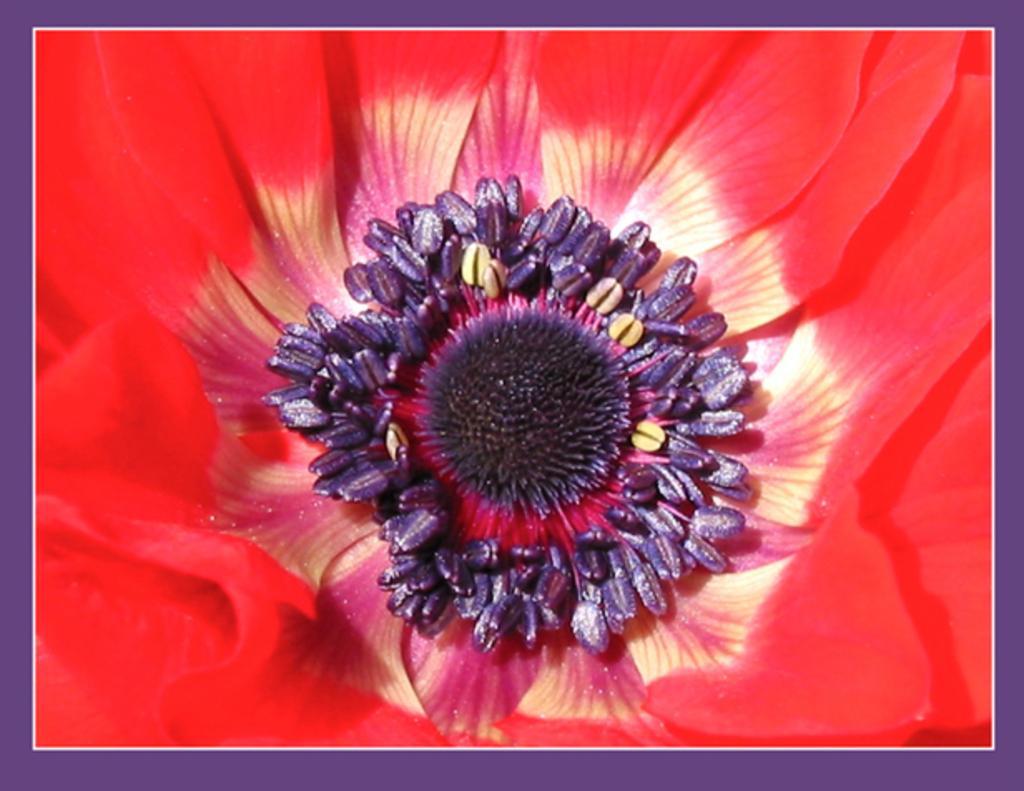Can you describe this image briefly? In this image there is a flower. 